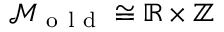Convert formula to latex. <formula><loc_0><loc_0><loc_500><loc_500>\mathcal { M } _ { o l d } \cong \mathbb { R } \times \mathbb { Z }</formula> 